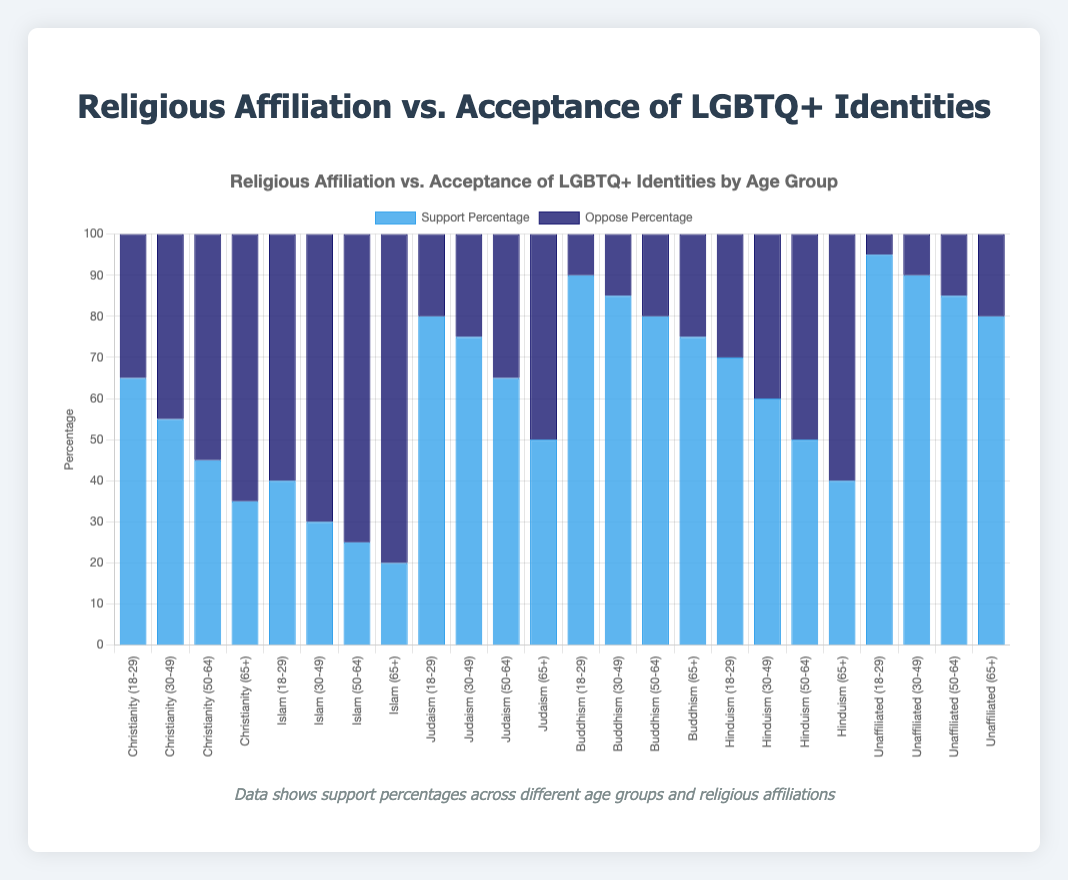What's the overall trend in Support Percentage as age increases for Christianity? As age increases, the Support Percentage for Christianity decreases. Specifically, it starts at 65% for the 18-29 group, drops to 55% for the 30-49 group, then to 45% for the 50-64 group, and finally to 35% for the 65+ group.
Answer: Decreases How does the Support Percentage for Judaism in the 18-29 age group compare to that in the 65+ age group? The Support Percentage for Judaism in the 18-29 age group is 80%, whereas in the 65+ age group it is 50%. This shows a decrease of 30% as age increases.
Answer: 80% vs. 50% Among Buddhism and Christianity, which religious affiliation has a higher Support Percentage in the 50-64 age group? In the 50-64 age group, Buddhism has a Support Percentage of 80%, whereas Christianity has a Support Percentage of 45%. Buddhism thus has a higher Support Percentage.
Answer: Buddhism What is the combined Oppose Percentage for Islam across all age groups? The Oppose Percentages for Islam are 60% for 18-29, 70% for 30-49, 75% for 50-64, and 80% for 65+. Summing these up: 60 + 70 + 75 + 80 = 285%.
Answer: 285% Which age group of Hinduism shows the greatest difference between Support and Oppose Percentages? For Hinduism, the differences are as follows: 18-29 (70% support - 30% oppose = 40%), 30-49 (60% support - 40% oppose = 20%), 50-64 (50% support - 50% oppose = 0%), and 65+ (40% support - 60% oppose = -20%). The greatest difference is observed in the 18-29 age group with a difference of 40%.
Answer: 18-29 What is the lowest Support Percentage across all age groups and religious affiliations? Among all the data points, the lowest Support Percentage is observed in Islam for the 65+ age group, which is 20%.
Answer: 20% Compare the visual height of the Support and Oppose bars for the Unaffiliated group in the 30-49 age group. Which bar is taller? In the 30-49 age group of the Unaffiliated group, the Support Percentage is 90%, and the Oppose Percentage is 10%. Visually, the Support bar is much taller than the Oppose bar.
Answer: Support bar Which religious affiliation has the most consistent Support Percentage across all age groups? Buddhism shows consistent high Support Percentages: 90%, 85%, 80%, and 75% across age groups 18-29, 30-49, 50-64, and 65+, respectively.
Answer: Buddhism For the age group 65+, which religious affiliation has the highest Support Percentage? For the 65+ age group, the Unaffiliated group has the highest Support Percentage at 80%.
Answer: Unaffiliated What is the overall difference in Support Percentage between the 18-29 and 65+ age groups for Hinduism? For Hinduism, the Support Percentage for the 18-29 age group is 70% and for the 65+ age group is 40%. The difference is 70% - 40% = 30%.
Answer: 30% 